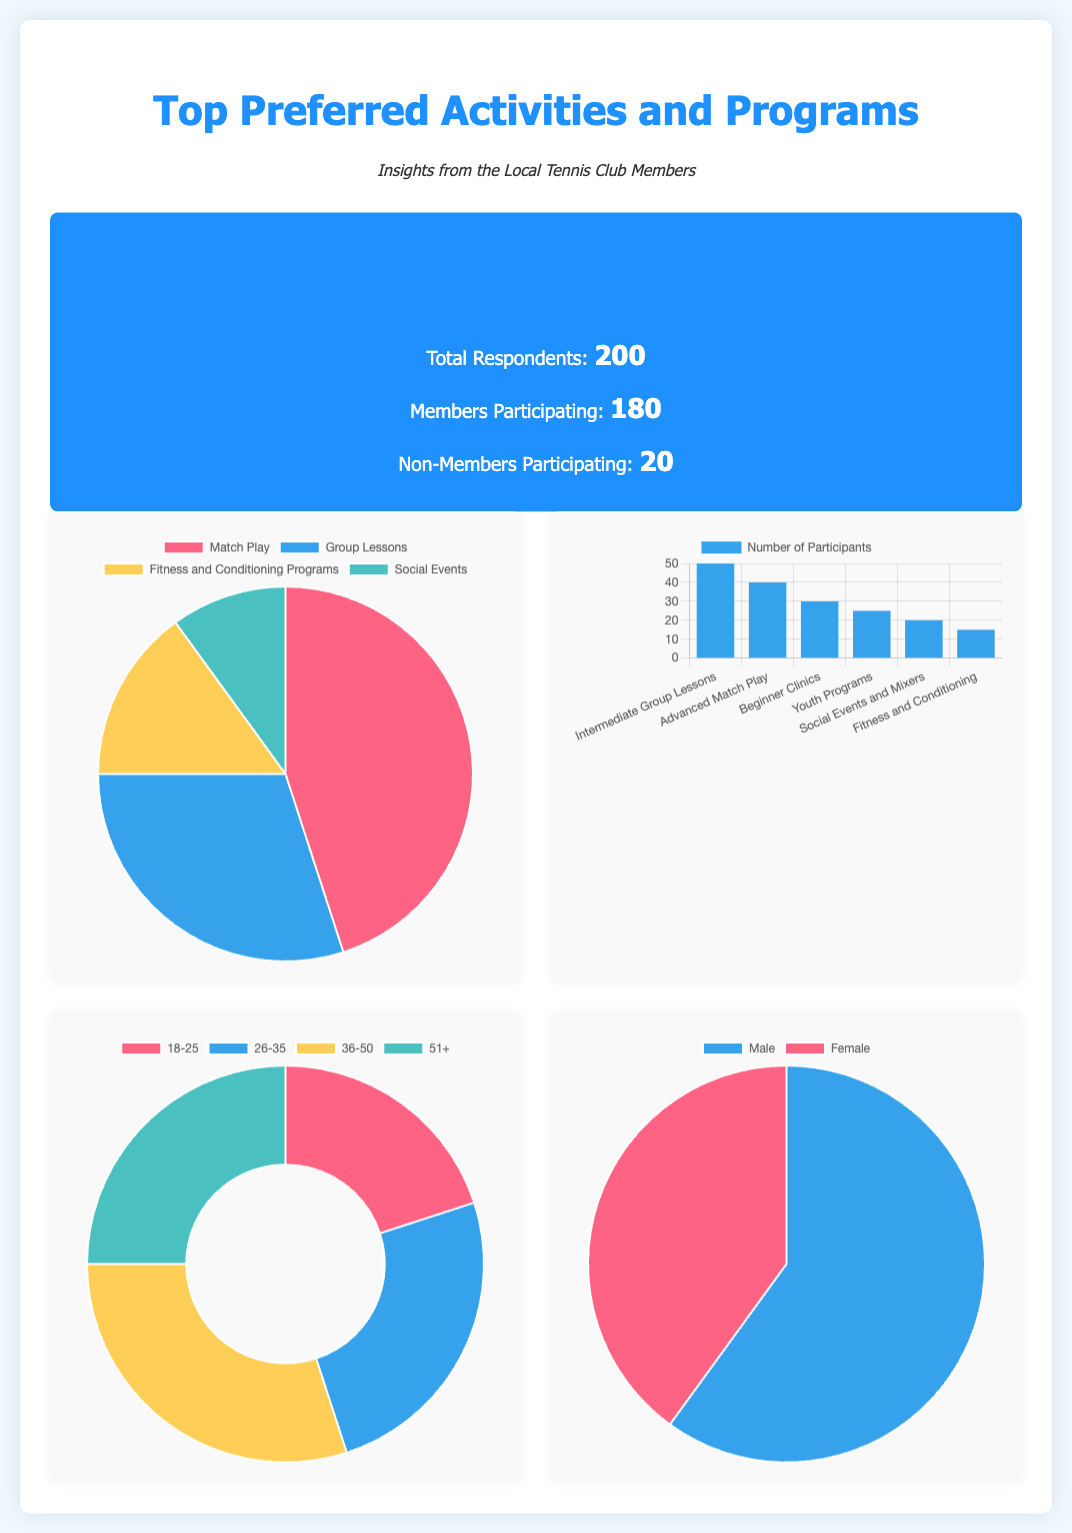What is the total number of respondents? The total number of respondents is stated in the survey info section of the document, which is 200.
Answer: 200 How many members participated in the survey? The number of members participating is highlighted in the survey info section, which is 180.
Answer: 180 What is the most preferred activity according to the pie chart? The most preferred activity is identified in the top preferred activities chart, which is Match Play.
Answer: Match Play How many participants were involved in Intermediate Group Lessons? The number of participants in Intermediate Group Lessons is noted in the program participation bar chart, which is 50.
Answer: 50 What percentage of respondents identified as Female? The gender distribution pie chart shows that 40% of respondents are Female.
Answer: 40 Which age group has the highest participation rate? The age group with the highest participation rate is indicated in the age groups doughnut chart, which is 36-50.
Answer: 36-50 What is the participation rate of Youth Programs? The participation rate for Youth Programs is found in the program participation bar chart, which is 25.
Answer: 25 How many total non-members participated in the survey? The total number of non-members participating is mentioned in the survey info section, which is 20.
Answer: 20 